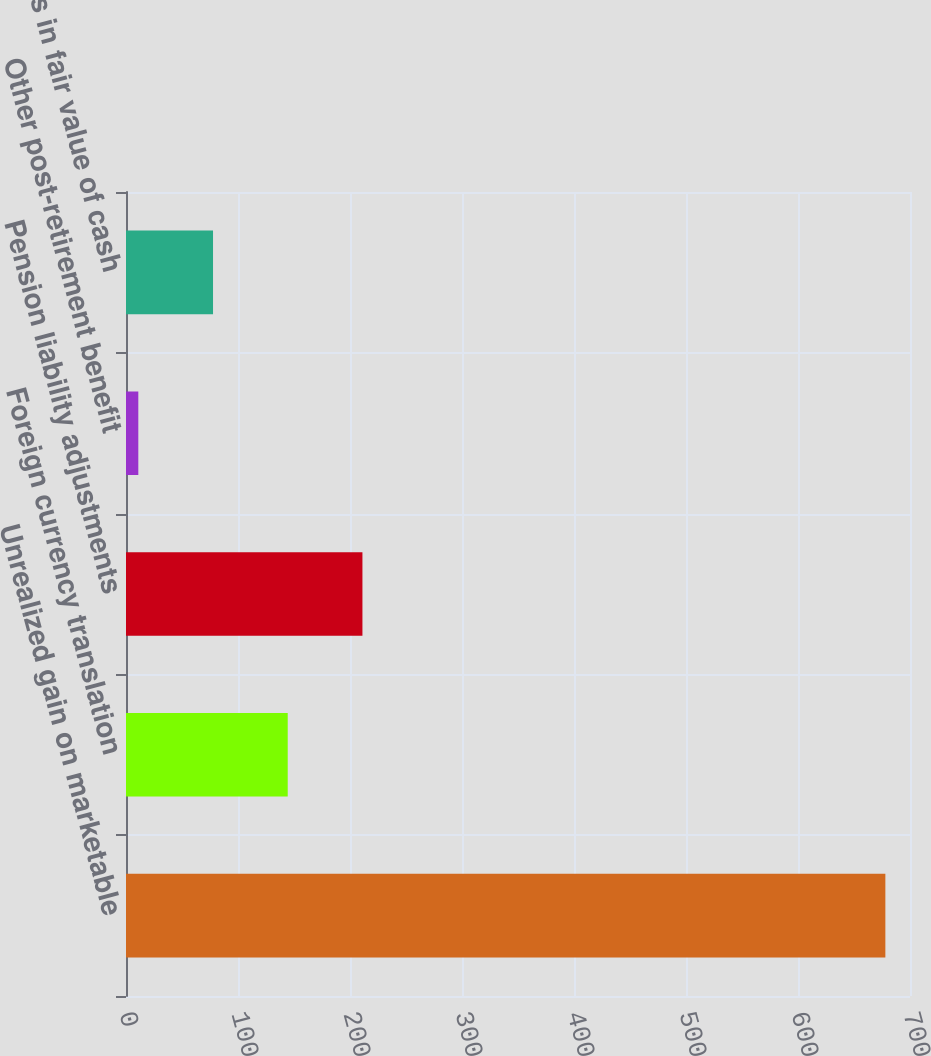<chart> <loc_0><loc_0><loc_500><loc_500><bar_chart><fcel>Unrealized gain on marketable<fcel>Foreign currency translation<fcel>Pension liability adjustments<fcel>Other post-retirement benefit<fcel>Changes in fair value of cash<nl><fcel>678<fcel>144.4<fcel>211.1<fcel>11<fcel>77.7<nl></chart> 